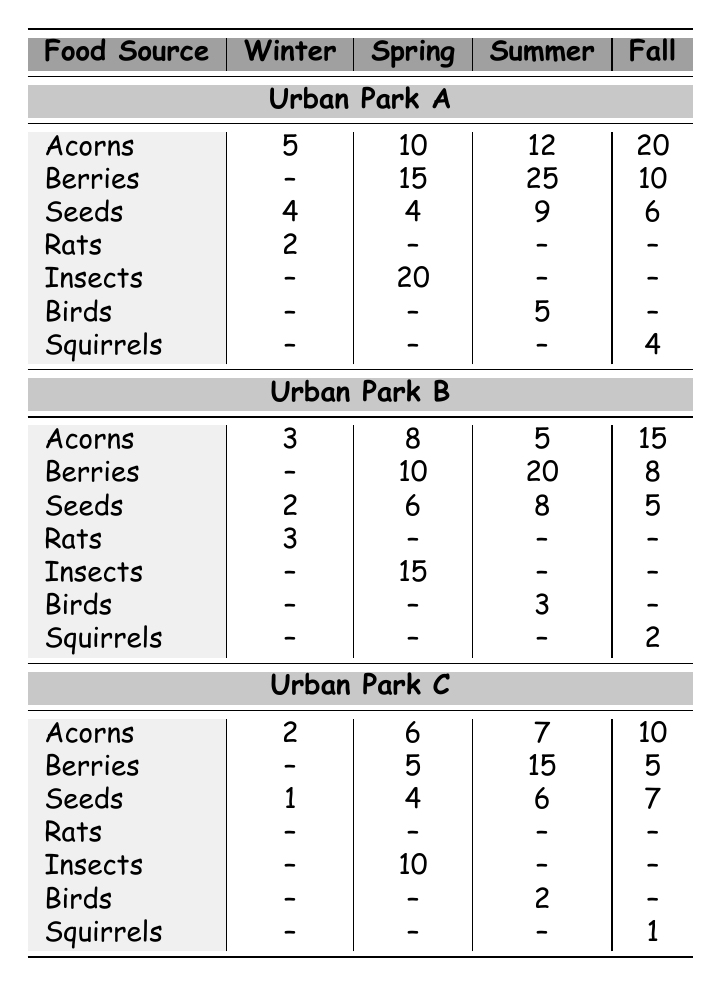What is the highest amount of Berries found in Urban Park A? In Urban Park A, the highest amount of Berries is during Spring, with 15 units.
Answer: 15 What food source is available in the least quantity in Urban Park C during Winter? In Winter, Urban Park C has 2 Acorns, 0 Berries, 1 Seed, and 0 Rats. The least quantity is 0 Berries and 0 Rats.
Answer: 0 Which season has the most Acorns available in Urban Park B? In Urban Park B, the most Acorns are available in Fall with 15 units.
Answer: 15 What is the total amount of food sources available in Urban Park A during Summer? In Summer, Urban Park A has 12 Acorns, 25 Berries, 9 Seeds, and 5 Birds. The total is 12 + 25 + 9 + 5 = 51.
Answer: 51 Do Urban Park C and Urban Park A have the same amount of Seeds in Fall? In Fall, Urban Park A has 6 Seeds, while Urban Park C has 7 Seeds, so they do not have the same amount.
Answer: No What food source is only available in Spring across all parks? In Spring, Insects are only available in Urban Park A (20), Urban Park B (15), and Urban Park C (10). All other food sources are also available in other seasons.
Answer: Insects Which Park has the highest total food availability across all seasons? To find this, sum the food sources for each park: Urban Park A: 5 + 15 + 12 + 20 + 4 + 20 + 5 + 4 = 85; Urban Park B: 3 + 10 + 20 + 15 + 2 + 15 + 3 + 2 = 80; Urban Park C: 2 + 5 + 15 + 7 + 1 + 10 + 2 + 1 = 43. Urban Park A has the highest total of 85.
Answer: Urban Park A How many more units of Seeds are available in Urban Park A during Summer compared to Winter? In Urban Park A, there are 9 Seeds in Summer and 4 Seeds in Winter. The difference is 9 - 4 = 5.
Answer: 5 Is there any season where Rats are available in Urban Park C? In the table, there are no units of Rats listed for Urban Park C in any season, indicating they are not available at any time.
Answer: No What is the average amount of Berries across all urban parks in Fall? In Fall, the amounts of Berries are 10 (Park A), 8 (Park B), and 5 (Park C). The sum is 10 + 8 + 5 = 23, and the average is 23 / 3 = 7.67.
Answer: 7.67 Which food source has decreased in availability from Spring to Winter in Urban Park B? In Urban Park B, Acorns decreased from 8 in Spring to 3 in Winter; Berries decreased from 10 in Spring to 0 in Winter; and Seeds decreased from 6 in Spring to 2 in Winter. All nutrient sources decreased.
Answer: Acorns, Berries, and Seeds 